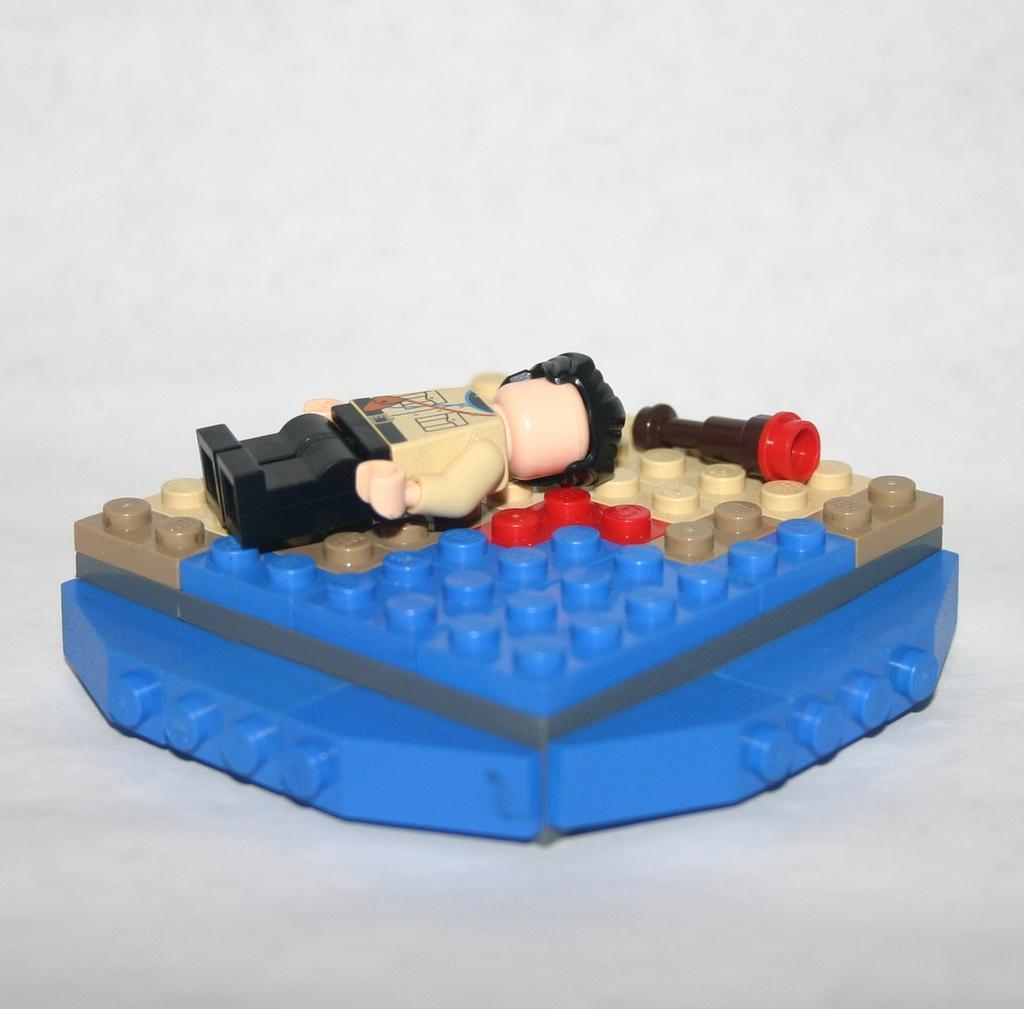Please provide a concise description of this image. In this image there is a toy on the surface, the background of the image is white in color. 